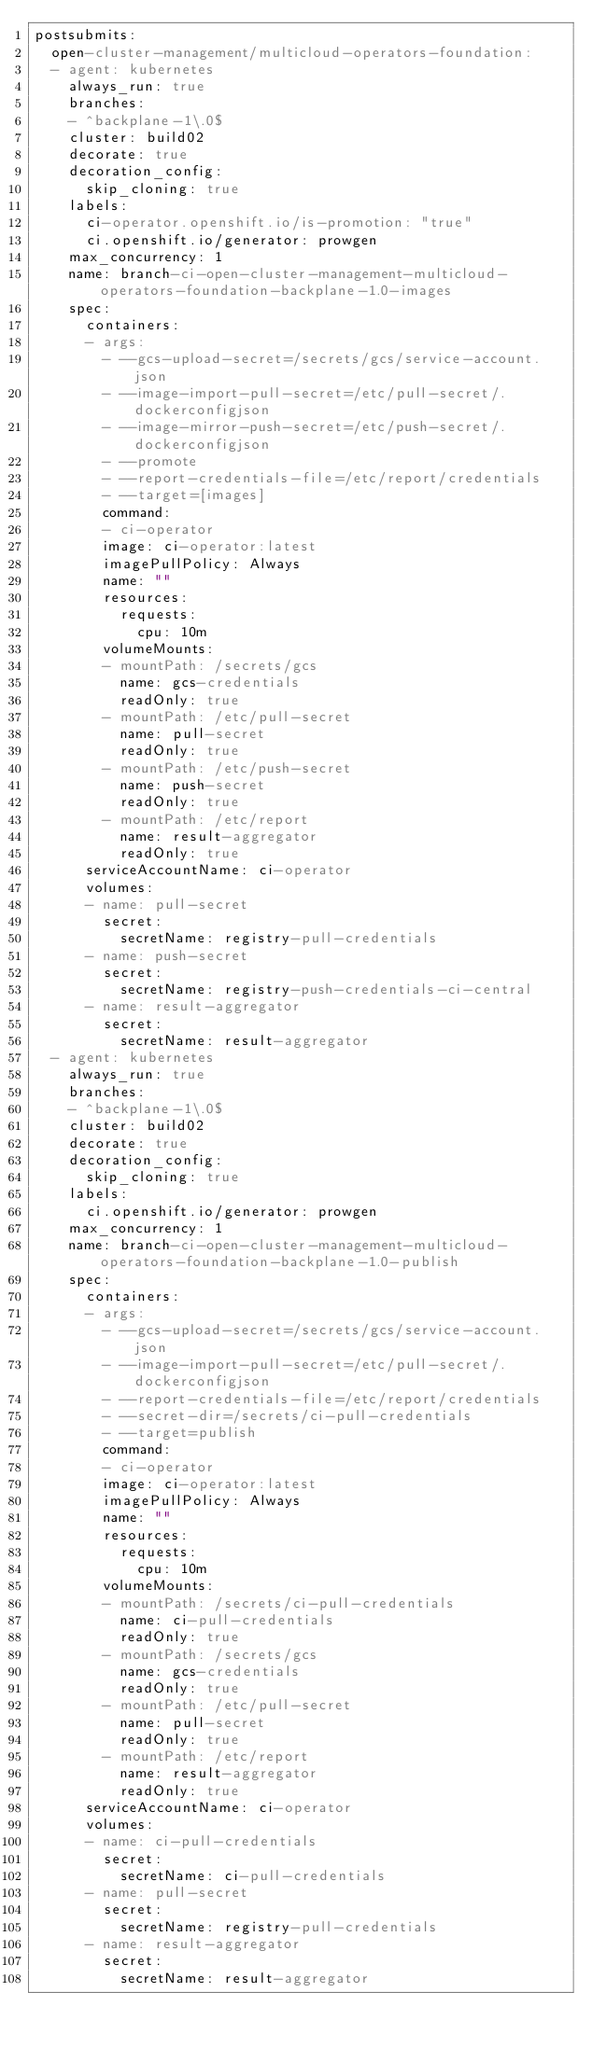Convert code to text. <code><loc_0><loc_0><loc_500><loc_500><_YAML_>postsubmits:
  open-cluster-management/multicloud-operators-foundation:
  - agent: kubernetes
    always_run: true
    branches:
    - ^backplane-1\.0$
    cluster: build02
    decorate: true
    decoration_config:
      skip_cloning: true
    labels:
      ci-operator.openshift.io/is-promotion: "true"
      ci.openshift.io/generator: prowgen
    max_concurrency: 1
    name: branch-ci-open-cluster-management-multicloud-operators-foundation-backplane-1.0-images
    spec:
      containers:
      - args:
        - --gcs-upload-secret=/secrets/gcs/service-account.json
        - --image-import-pull-secret=/etc/pull-secret/.dockerconfigjson
        - --image-mirror-push-secret=/etc/push-secret/.dockerconfigjson
        - --promote
        - --report-credentials-file=/etc/report/credentials
        - --target=[images]
        command:
        - ci-operator
        image: ci-operator:latest
        imagePullPolicy: Always
        name: ""
        resources:
          requests:
            cpu: 10m
        volumeMounts:
        - mountPath: /secrets/gcs
          name: gcs-credentials
          readOnly: true
        - mountPath: /etc/pull-secret
          name: pull-secret
          readOnly: true
        - mountPath: /etc/push-secret
          name: push-secret
          readOnly: true
        - mountPath: /etc/report
          name: result-aggregator
          readOnly: true
      serviceAccountName: ci-operator
      volumes:
      - name: pull-secret
        secret:
          secretName: registry-pull-credentials
      - name: push-secret
        secret:
          secretName: registry-push-credentials-ci-central
      - name: result-aggregator
        secret:
          secretName: result-aggregator
  - agent: kubernetes
    always_run: true
    branches:
    - ^backplane-1\.0$
    cluster: build02
    decorate: true
    decoration_config:
      skip_cloning: true
    labels:
      ci.openshift.io/generator: prowgen
    max_concurrency: 1
    name: branch-ci-open-cluster-management-multicloud-operators-foundation-backplane-1.0-publish
    spec:
      containers:
      - args:
        - --gcs-upload-secret=/secrets/gcs/service-account.json
        - --image-import-pull-secret=/etc/pull-secret/.dockerconfigjson
        - --report-credentials-file=/etc/report/credentials
        - --secret-dir=/secrets/ci-pull-credentials
        - --target=publish
        command:
        - ci-operator
        image: ci-operator:latest
        imagePullPolicy: Always
        name: ""
        resources:
          requests:
            cpu: 10m
        volumeMounts:
        - mountPath: /secrets/ci-pull-credentials
          name: ci-pull-credentials
          readOnly: true
        - mountPath: /secrets/gcs
          name: gcs-credentials
          readOnly: true
        - mountPath: /etc/pull-secret
          name: pull-secret
          readOnly: true
        - mountPath: /etc/report
          name: result-aggregator
          readOnly: true
      serviceAccountName: ci-operator
      volumes:
      - name: ci-pull-credentials
        secret:
          secretName: ci-pull-credentials
      - name: pull-secret
        secret:
          secretName: registry-pull-credentials
      - name: result-aggregator
        secret:
          secretName: result-aggregator
</code> 